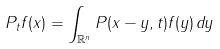<formula> <loc_0><loc_0><loc_500><loc_500>P _ { t } f ( x ) = \int _ { \mathbb { R } ^ { n } } P ( x - y , t ) f ( y ) \, d y</formula> 